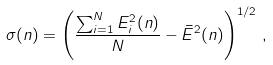Convert formula to latex. <formula><loc_0><loc_0><loc_500><loc_500>\sigma ( n ) = \left ( \frac { \sum _ { i = 1 } ^ { N } E _ { i } ^ { 2 } ( { n } ) } { N } - \bar { E } ^ { 2 } ( { n } ) \right ) ^ { 1 / 2 } \, ,</formula> 